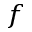<formula> <loc_0><loc_0><loc_500><loc_500>^ { f }</formula> 